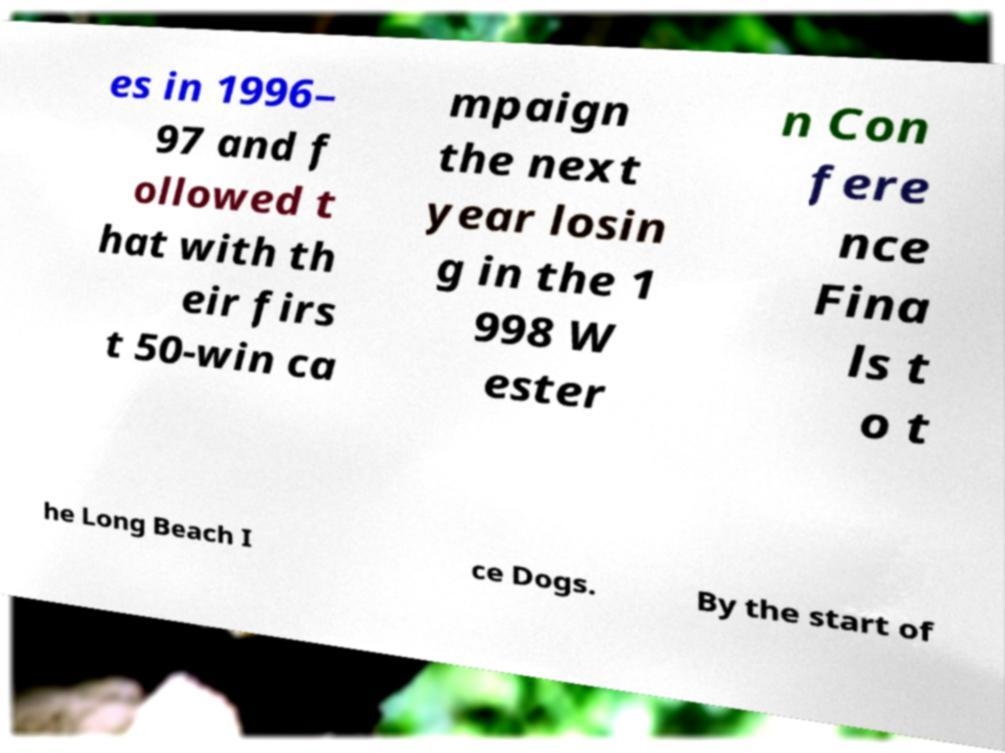For documentation purposes, I need the text within this image transcribed. Could you provide that? es in 1996– 97 and f ollowed t hat with th eir firs t 50-win ca mpaign the next year losin g in the 1 998 W ester n Con fere nce Fina ls t o t he Long Beach I ce Dogs. By the start of 